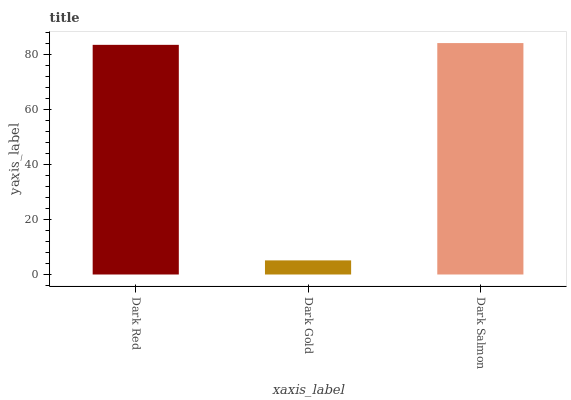Is Dark Gold the minimum?
Answer yes or no. Yes. Is Dark Salmon the maximum?
Answer yes or no. Yes. Is Dark Salmon the minimum?
Answer yes or no. No. Is Dark Gold the maximum?
Answer yes or no. No. Is Dark Salmon greater than Dark Gold?
Answer yes or no. Yes. Is Dark Gold less than Dark Salmon?
Answer yes or no. Yes. Is Dark Gold greater than Dark Salmon?
Answer yes or no. No. Is Dark Salmon less than Dark Gold?
Answer yes or no. No. Is Dark Red the high median?
Answer yes or no. Yes. Is Dark Red the low median?
Answer yes or no. Yes. Is Dark Salmon the high median?
Answer yes or no. No. Is Dark Salmon the low median?
Answer yes or no. No. 